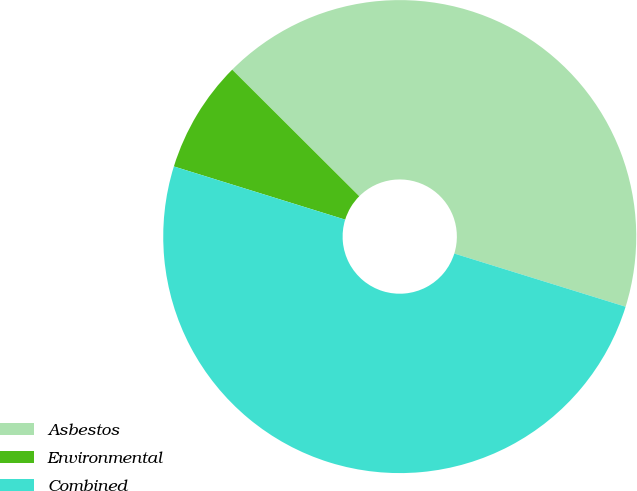Convert chart. <chart><loc_0><loc_0><loc_500><loc_500><pie_chart><fcel>Asbestos<fcel>Environmental<fcel>Combined<nl><fcel>42.32%<fcel>7.68%<fcel>50.0%<nl></chart> 